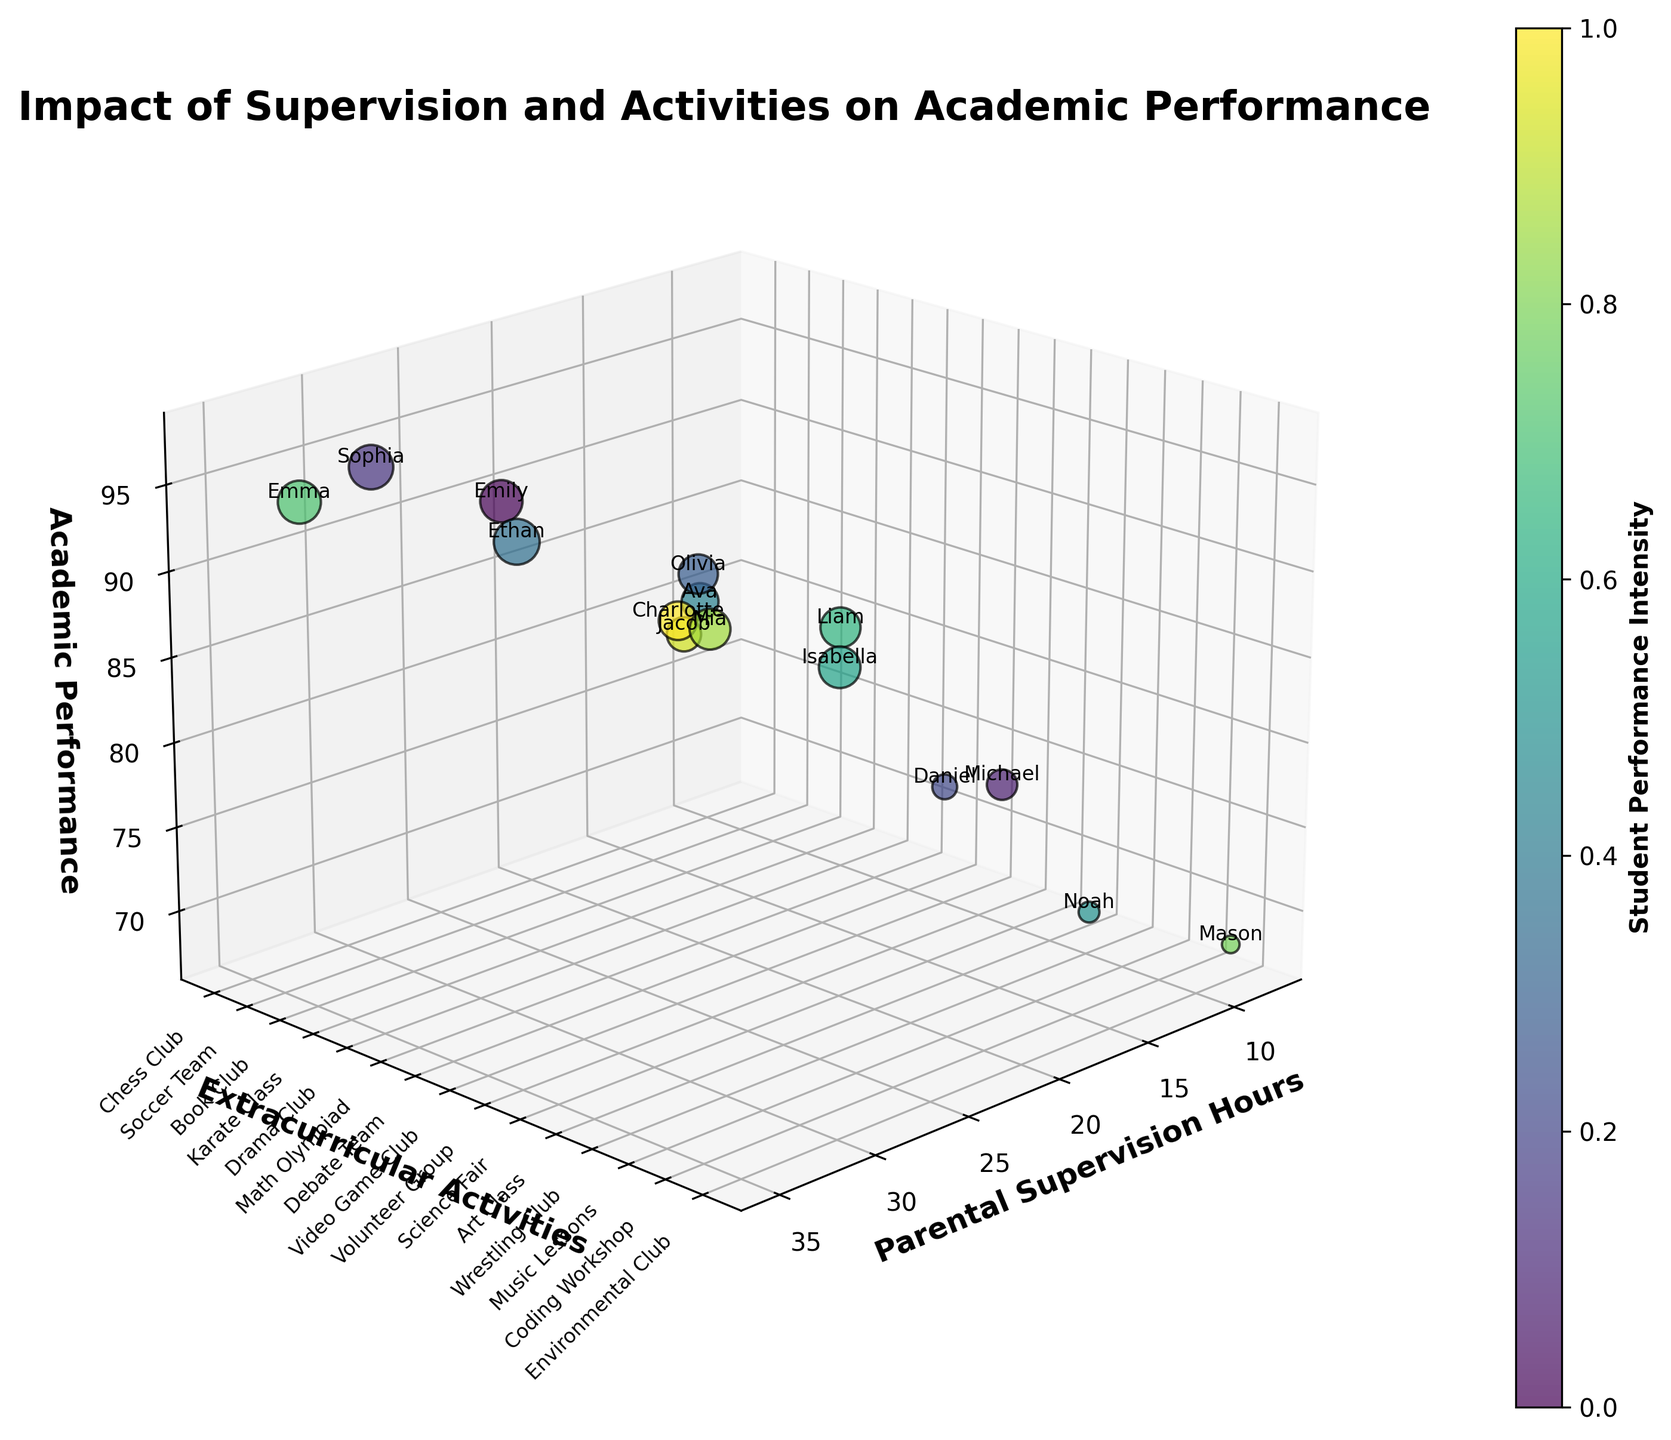How many data points are visualized in the figure? By counting each bubble in the 3D scatter plot, you can determine the number of data points represented. Each student's data is depicted by one bubble on the plot.
Answer: 15 What is the title of the figure? The title is usually located at the top of the figure, providing an overview of what is being displayed.
Answer: Impact of Supervision and Activities on Academic Performance Which student's academic performance is the highest, and what extracurricular activity are they involved in? Locate the highest point on the academic performance axis (z-axis) and identify the corresponding student's label and their associated extracurricular activity label.
Answer: Ethan, Math Olympiad What is the median Parental Supervision Hours among all the students? To determine the median, list the Parental Supervision Hours values in ascending order and find the middle value. The order is: 8, 10, 12, 15, 17, 18, 20, 22, 23, 25, 27, 28, 30, 32, 35, and the middle value is the 8th, which is 22.
Answer: 22 How does Mason's academic performance compare to the other students'? Look for Mason's bubble on the plot and compare its position on the academic performance axis (z-axis) with the other bubbles.
Answer: Mason's academic performance is one of the lowest Which extracurricular activity category appears most frequently? Count the number of bubbles associated with each category on the y-axis label (Extracurricular Activities) and identify the one with the highest count.
Answer: Music Lessons, Chess Club, Book Club, Drama Club, Math Olympiad, Debate Team, Video Game Club, Karate Class, Volunteer Group, Science Fair, Art Class, Coding Workshop, Environmental Club, Wrestling Club; they all appear once except Drama Club (2) Is there a visible trend between Parental Supervision Hours and Academic Performance? Observe the scatter plot to see if increasing or decreasing Parental Supervision Hours corresponds to changes in Academic Performance (look for clusters or lines).
Answer: Higher supervision often correlates with higher academic performance Which student has the lowest academic performance, and what type of extracurricular activity are they involved in? Identify the lowest point on the academic performance axis (z-axis) and find the corresponding student’s label and extracurricular activity.
Answer: Mason, Wrestling Club Do students with more hours of parental supervision tend to have larger or smaller bubbles in the figure? Compare the size of the bubbles representing students with higher Parental Supervision Hours to those with lower hours. Larger bubbles indicate higher academic performance.
Answer: Larger bubbles How does parental supervision vary between students in academic-oriented activities (like Math Olympiad or Book Club) and sports-oriented activities (like Soccer Team or Karate Class)? Identify the bubbles corresponding to academic and sports activities and compare their positions on the Parental Supervision Hours axis (x-axis).
Answer: Academic-oriented activities often have higher parental supervision hours compared to sports-oriented activities 